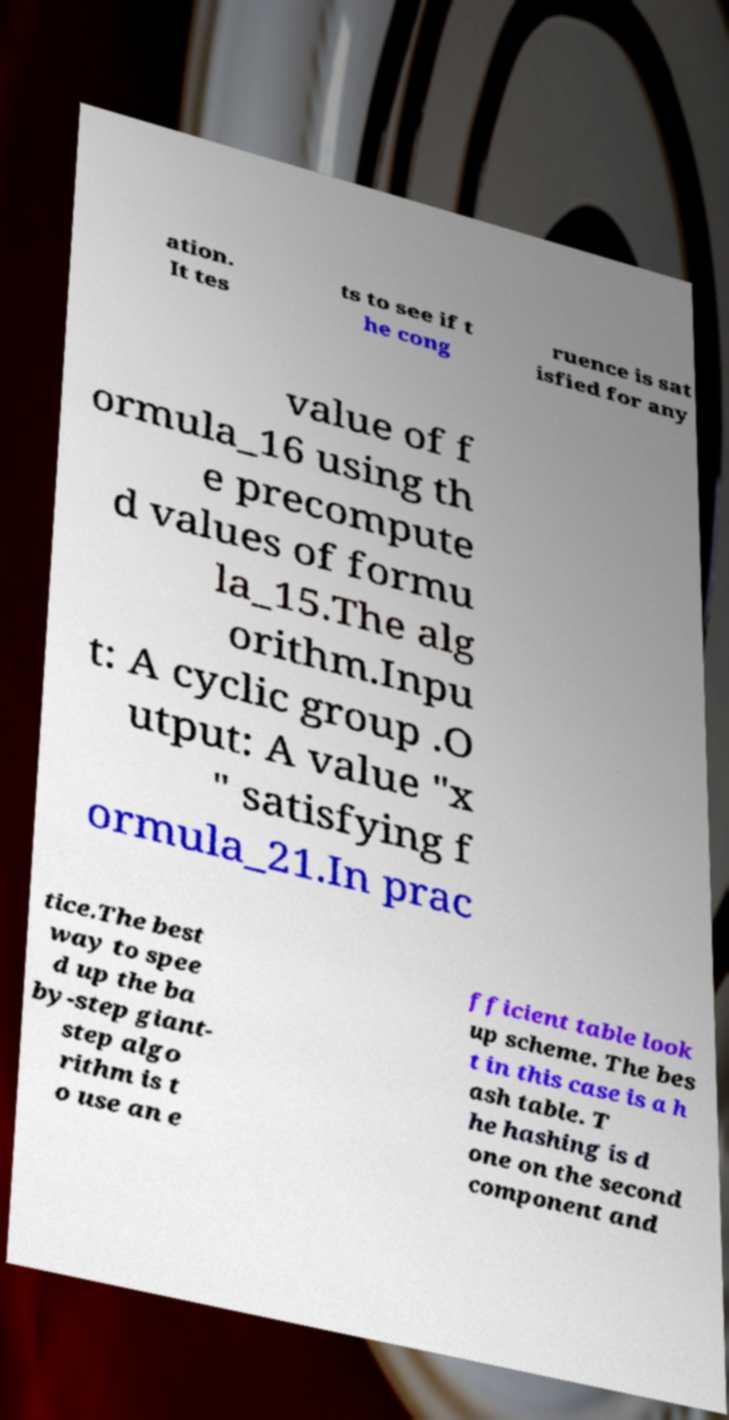For documentation purposes, I need the text within this image transcribed. Could you provide that? ation. It tes ts to see if t he cong ruence is sat isfied for any value of f ormula_16 using th e precompute d values of formu la_15.The alg orithm.Inpu t: A cyclic group .O utput: A value "x " satisfying f ormula_21.In prac tice.The best way to spee d up the ba by-step giant- step algo rithm is t o use an e fficient table look up scheme. The bes t in this case is a h ash table. T he hashing is d one on the second component and 